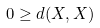Convert formula to latex. <formula><loc_0><loc_0><loc_500><loc_500>0 \geq d ( X , X )</formula> 